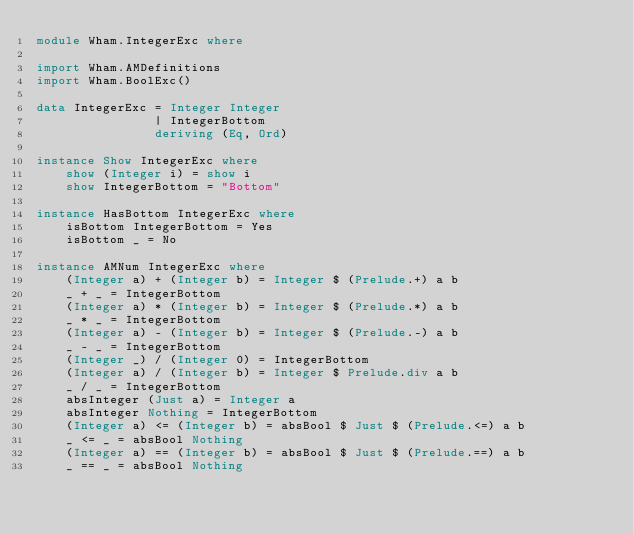<code> <loc_0><loc_0><loc_500><loc_500><_Haskell_>module Wham.IntegerExc where

import Wham.AMDefinitions
import Wham.BoolExc()

data IntegerExc = Integer Integer
                | IntegerBottom
                deriving (Eq, Ord)

instance Show IntegerExc where
    show (Integer i) = show i
    show IntegerBottom = "Bottom"

instance HasBottom IntegerExc where
    isBottom IntegerBottom = Yes
    isBottom _ = No

instance AMNum IntegerExc where
    (Integer a) + (Integer b) = Integer $ (Prelude.+) a b
    _ + _ = IntegerBottom
    (Integer a) * (Integer b) = Integer $ (Prelude.*) a b
    _ * _ = IntegerBottom
    (Integer a) - (Integer b) = Integer $ (Prelude.-) a b
    _ - _ = IntegerBottom
    (Integer _) / (Integer 0) = IntegerBottom
    (Integer a) / (Integer b) = Integer $ Prelude.div a b
    _ / _ = IntegerBottom
    absInteger (Just a) = Integer a
    absInteger Nothing = IntegerBottom
    (Integer a) <= (Integer b) = absBool $ Just $ (Prelude.<=) a b
    _ <= _ = absBool Nothing
    (Integer a) == (Integer b) = absBool $ Just $ (Prelude.==) a b
    _ == _ = absBool Nothing</code> 